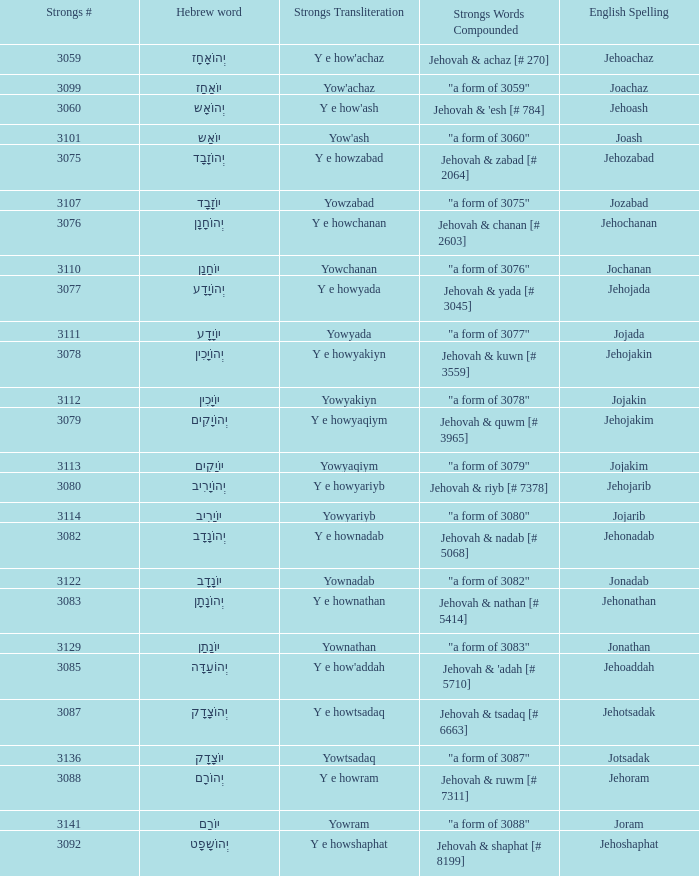What is the english spelling of the word with the strong's transliteration of y e howram? Jehoram. 